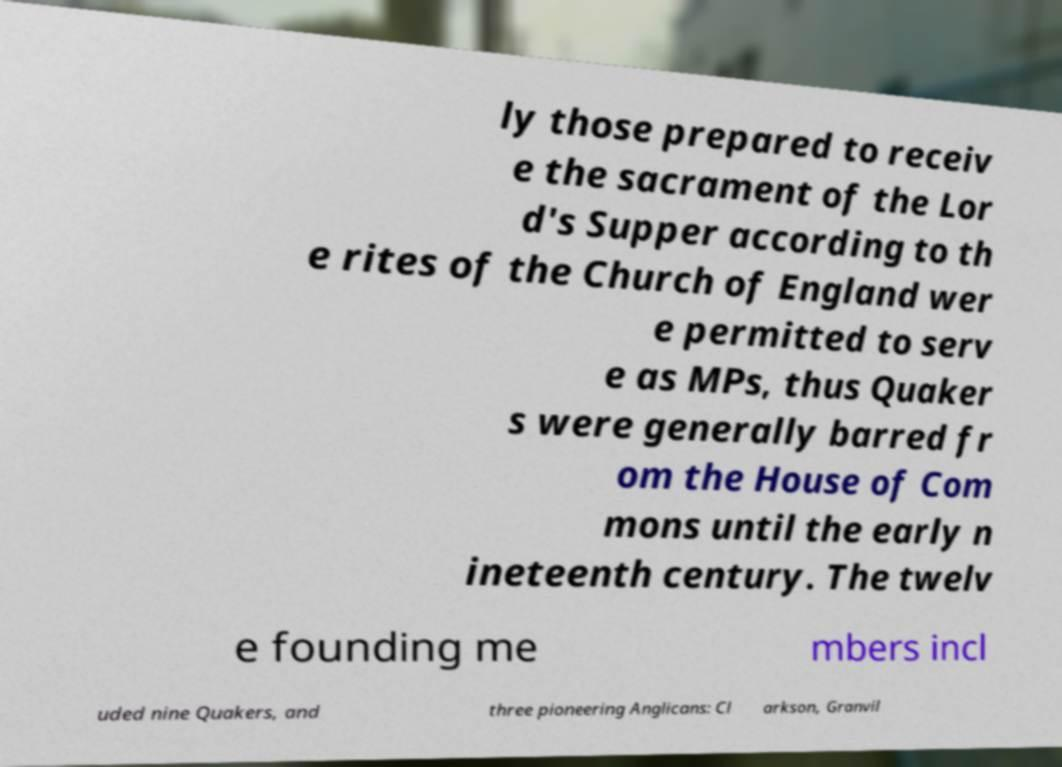Could you extract and type out the text from this image? ly those prepared to receiv e the sacrament of the Lor d's Supper according to th e rites of the Church of England wer e permitted to serv e as MPs, thus Quaker s were generally barred fr om the House of Com mons until the early n ineteenth century. The twelv e founding me mbers incl uded nine Quakers, and three pioneering Anglicans: Cl arkson, Granvil 